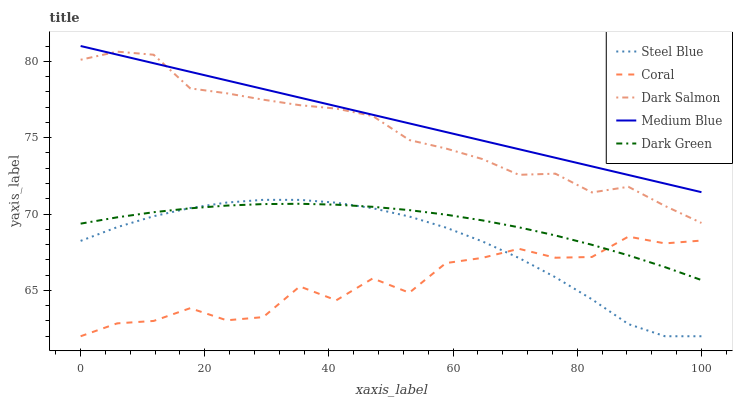Does Coral have the minimum area under the curve?
Answer yes or no. Yes. Does Medium Blue have the maximum area under the curve?
Answer yes or no. Yes. Does Dark Green have the minimum area under the curve?
Answer yes or no. No. Does Dark Green have the maximum area under the curve?
Answer yes or no. No. Is Medium Blue the smoothest?
Answer yes or no. Yes. Is Coral the roughest?
Answer yes or no. Yes. Is Dark Green the smoothest?
Answer yes or no. No. Is Dark Green the roughest?
Answer yes or no. No. Does Coral have the lowest value?
Answer yes or no. Yes. Does Dark Green have the lowest value?
Answer yes or no. No. Does Medium Blue have the highest value?
Answer yes or no. Yes. Does Dark Green have the highest value?
Answer yes or no. No. Is Coral less than Medium Blue?
Answer yes or no. Yes. Is Dark Salmon greater than Dark Green?
Answer yes or no. Yes. Does Coral intersect Dark Green?
Answer yes or no. Yes. Is Coral less than Dark Green?
Answer yes or no. No. Is Coral greater than Dark Green?
Answer yes or no. No. Does Coral intersect Medium Blue?
Answer yes or no. No. 